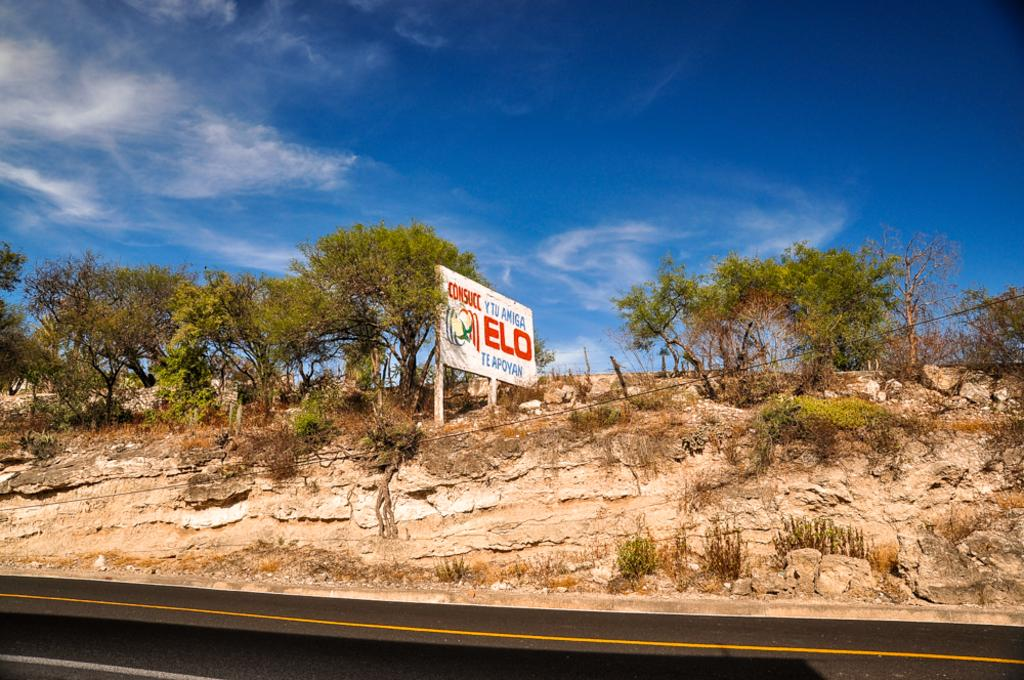What type of vegetation can be seen in the image? There are trees and grass in the image. What type of surface is visible in the image? There is a road in the image, with white and yellow lines visible on it. What is the condition of the sky in the image? The sky is cloudy and pale blue in the image. What is the purpose of the board with text in the image? The purpose of the board with text is not clear from the image alone, but it may be providing information or directions. Can you tell me how many streams are visible in the image? There are no streams visible in the image; it features trees, grass, a road, and a board with text. What type of base is supporting the trees in the image? The image does not show any specific base supporting the trees; they are growing naturally in the ground. 